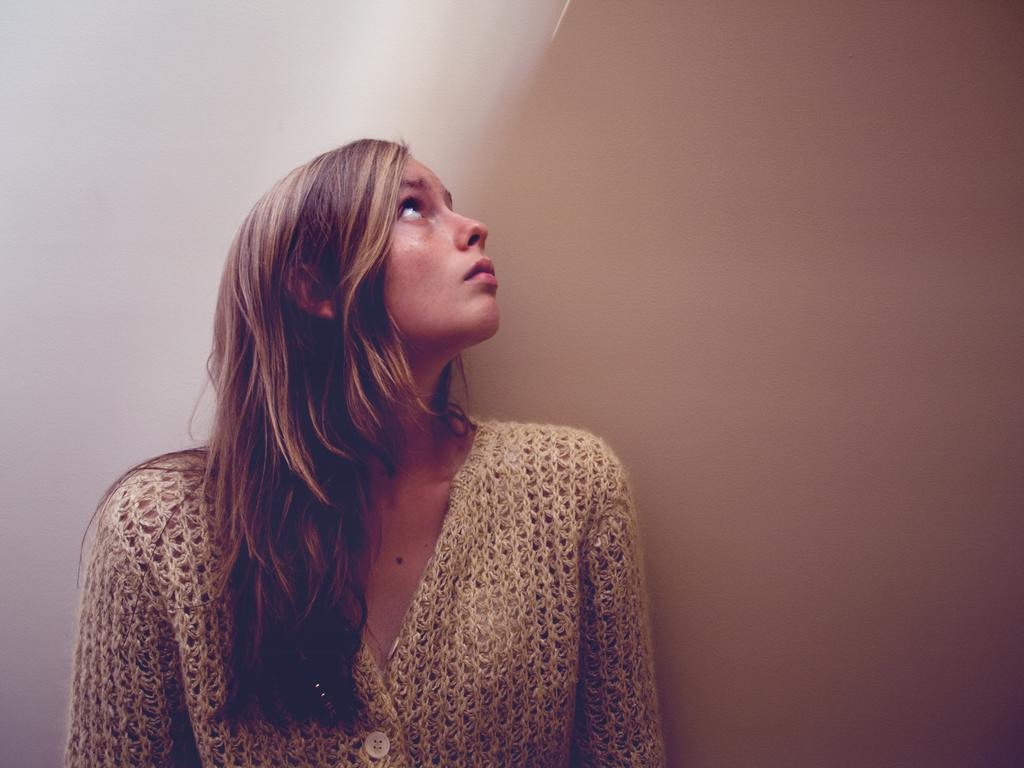Who is the main subject in the foreground of the image? There is a woman in the foreground of the image. What colors are present on the surfaces visible in the image? There are white and brown surfaces visible in the image. What direction is the committee facing in the image? There is no committee present in the image, so it is not possible to determine the direction they might be facing. 